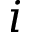Convert formula to latex. <formula><loc_0><loc_0><loc_500><loc_500>i</formula> 